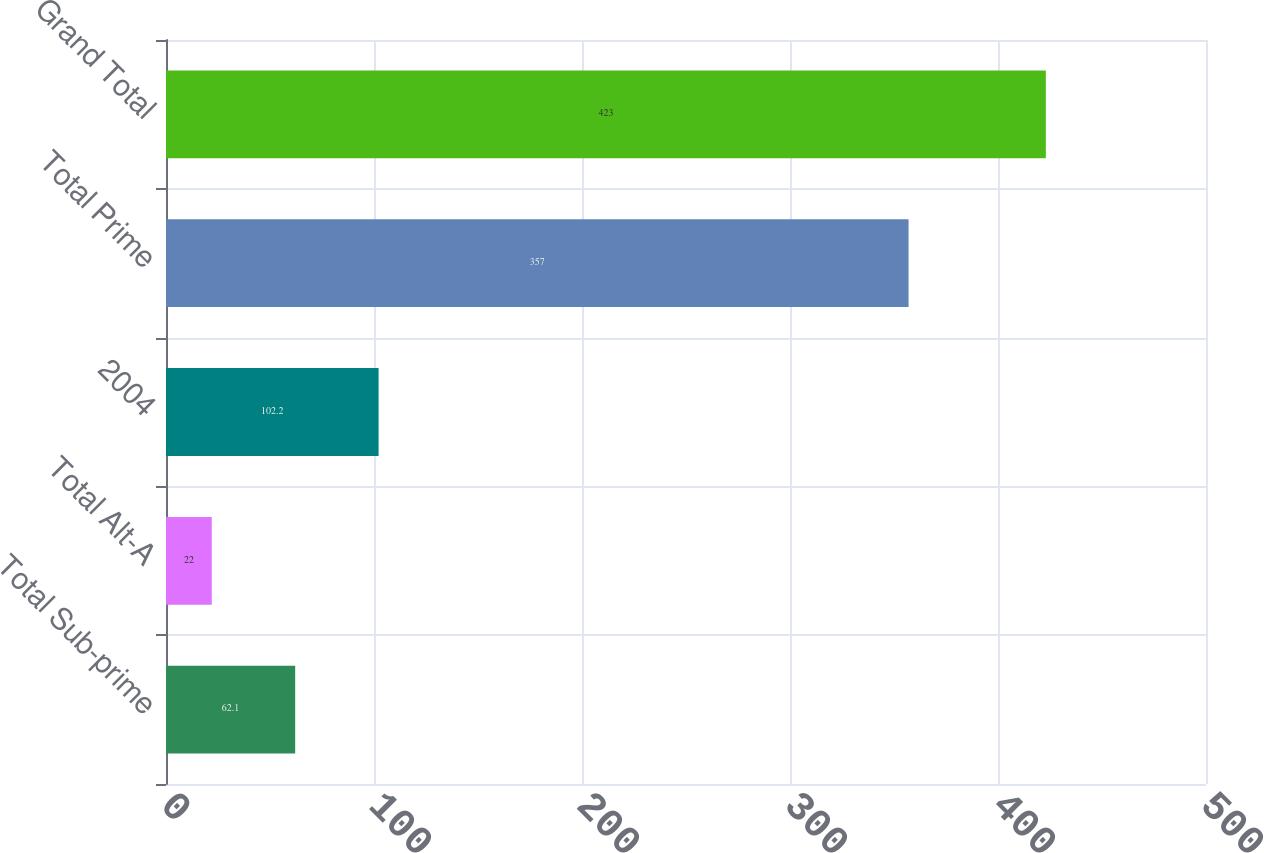Convert chart to OTSL. <chart><loc_0><loc_0><loc_500><loc_500><bar_chart><fcel>Total Sub-prime<fcel>Total Alt-A<fcel>2004<fcel>Total Prime<fcel>Grand Total<nl><fcel>62.1<fcel>22<fcel>102.2<fcel>357<fcel>423<nl></chart> 